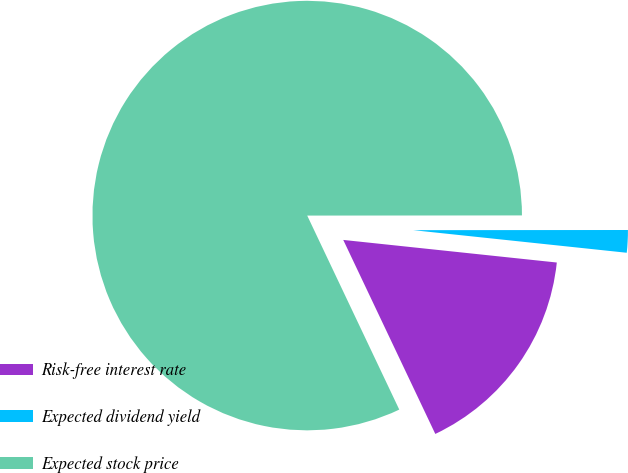Convert chart. <chart><loc_0><loc_0><loc_500><loc_500><pie_chart><fcel>Risk-free interest rate<fcel>Expected dividend yield<fcel>Expected stock price<nl><fcel>16.27%<fcel>1.69%<fcel>82.03%<nl></chart> 